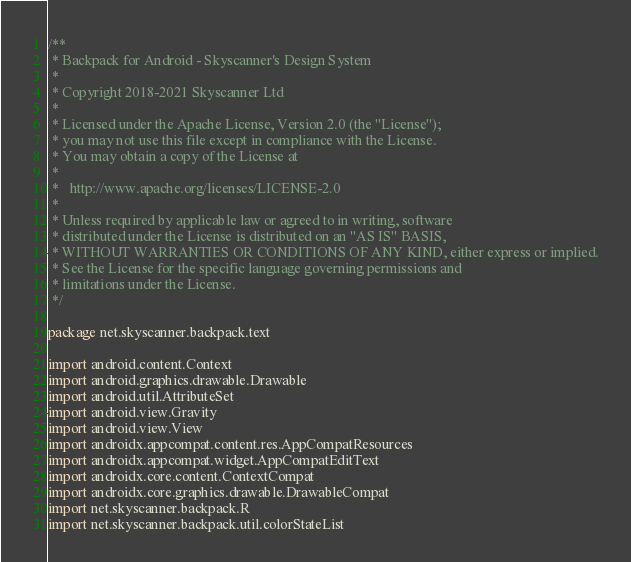<code> <loc_0><loc_0><loc_500><loc_500><_Kotlin_>/**
 * Backpack for Android - Skyscanner's Design System
 *
 * Copyright 2018-2021 Skyscanner Ltd
 *
 * Licensed under the Apache License, Version 2.0 (the "License");
 * you may not use this file except in compliance with the License.
 * You may obtain a copy of the License at
 *
 *   http://www.apache.org/licenses/LICENSE-2.0
 *
 * Unless required by applicable law or agreed to in writing, software
 * distributed under the License is distributed on an "AS IS" BASIS,
 * WITHOUT WARRANTIES OR CONDITIONS OF ANY KIND, either express or implied.
 * See the License for the specific language governing permissions and
 * limitations under the License.
 */

package net.skyscanner.backpack.text

import android.content.Context
import android.graphics.drawable.Drawable
import android.util.AttributeSet
import android.view.Gravity
import android.view.View
import androidx.appcompat.content.res.AppCompatResources
import androidx.appcompat.widget.AppCompatEditText
import androidx.core.content.ContextCompat
import androidx.core.graphics.drawable.DrawableCompat
import net.skyscanner.backpack.R
import net.skyscanner.backpack.util.colorStateList</code> 